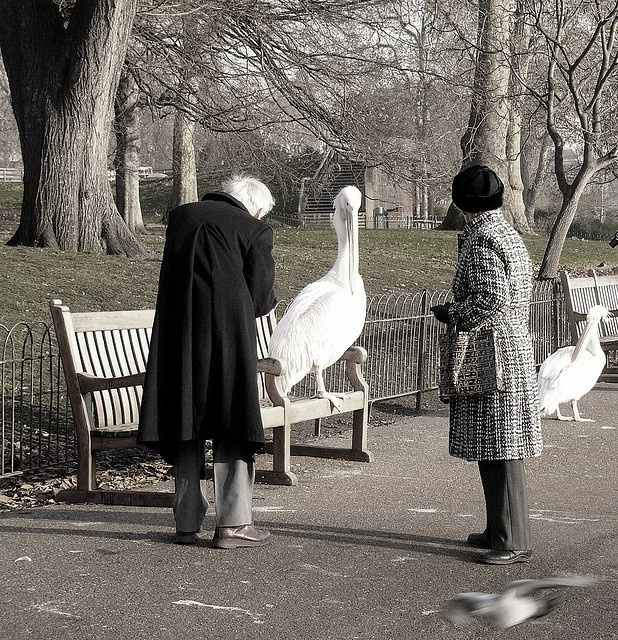Describe the objects in this image and their specific colors. I can see people in black, gray, darkgray, and ivory tones, people in black, gray, lightgray, and darkgray tones, bench in black, ivory, gray, and darkgray tones, bird in black, white, darkgray, gray, and lightgray tones, and bird in black, gray, darkgray, and lightgray tones in this image. 